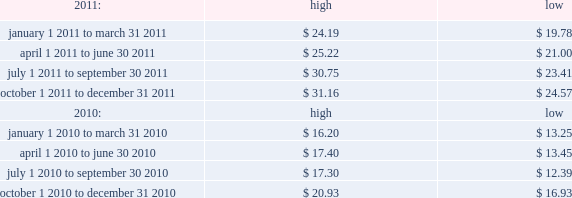Table of contents index to financial statements item 3 .
Legal proceedings .
Item 4 .
Mine safety disclosures .
Not applicable .
Part ii price range our common stock trades on the nasdaq global select market under the symbol 201cmktx 201d .
The range of closing price information for our common stock , as reported by nasdaq , was as follows : on february 16 , 2012 , the last reported closing price of our common stock on the nasdaq global select market was $ 32.65 .
Holders there were 41 holders of record of our common stock as of february 16 , 2012 .
Dividend policy we initiated a regular quarterly dividend in the fourth quarter of 2009 .
During 2010 and 2011 , we paid quarterly cash dividends of $ 0.07 per share and $ 0.09 per share , respectively .
In january 2012 , our board of directors approved a quarterly cash dividend of $ 0.11 per share payable on march 1 , 2012 to stockholders of record as of the close of business on february 16 , 2012 .
Any future declaration and payment of dividends will be at the sole discretion of the company 2019s board of directors .
The board of directors may take into account such matters as general business conditions , the company 2019s financial results , capital requirements , contractual , legal , and regulatory restrictions on the payment of dividends to the company 2019s stockholders or by the company 2019s subsidiaries to the parent and any such other factors as the board of directors may deem relevant .
Recent sales of unregistered securities item 5 .
Market for registrant 2019s common equity , related stockholder matters and issuer purchases of equity securities. .

During 2010 and 2011 what were total quarterly cash dividends per share? 
Computations: (0.07 + 0.09)
Answer: 0.16. 